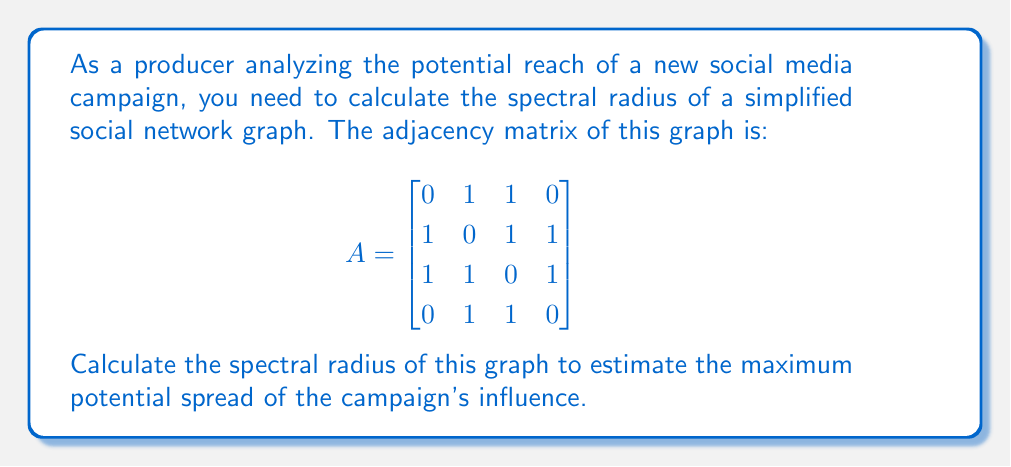Help me with this question. To calculate the spectral radius of the social network graph, we need to follow these steps:

1. Find the characteristic polynomial of the adjacency matrix A:
   $$det(A - \lambda I) = 0$$

2. Expand the determinant:
   $$\begin{vmatrix}
   -\lambda & 1 & 1 & 0 \\
   1 & -\lambda & 1 & 1 \\
   1 & 1 & -\lambda & 1 \\
   0 & 1 & 1 & -\lambda
   \end{vmatrix} = 0$$

3. Solve the characteristic equation:
   $$\lambda^4 - 3\lambda^2 - 2 = 0$$

4. This is a quadratic equation in $\lambda^2$. Let $u = \lambda^2$:
   $$u^2 - 3u - 2 = 0$$

5. Solve using the quadratic formula:
   $$u = \frac{3 \pm \sqrt{9 + 8}}{2} = \frac{3 \pm \sqrt{17}}{2}$$

6. Take the positive root:
   $$u = \frac{3 + \sqrt{17}}{2}$$

7. The spectral radius is the square root of this value:
   $$\rho(A) = \sqrt{\frac{3 + \sqrt{17}}{2}}$$

This spectral radius represents the maximum potential spread of influence in the network, which is crucial for estimating the campaign's reach and effectiveness.
Answer: $\sqrt{\frac{3 + \sqrt{17}}{2}}$ 